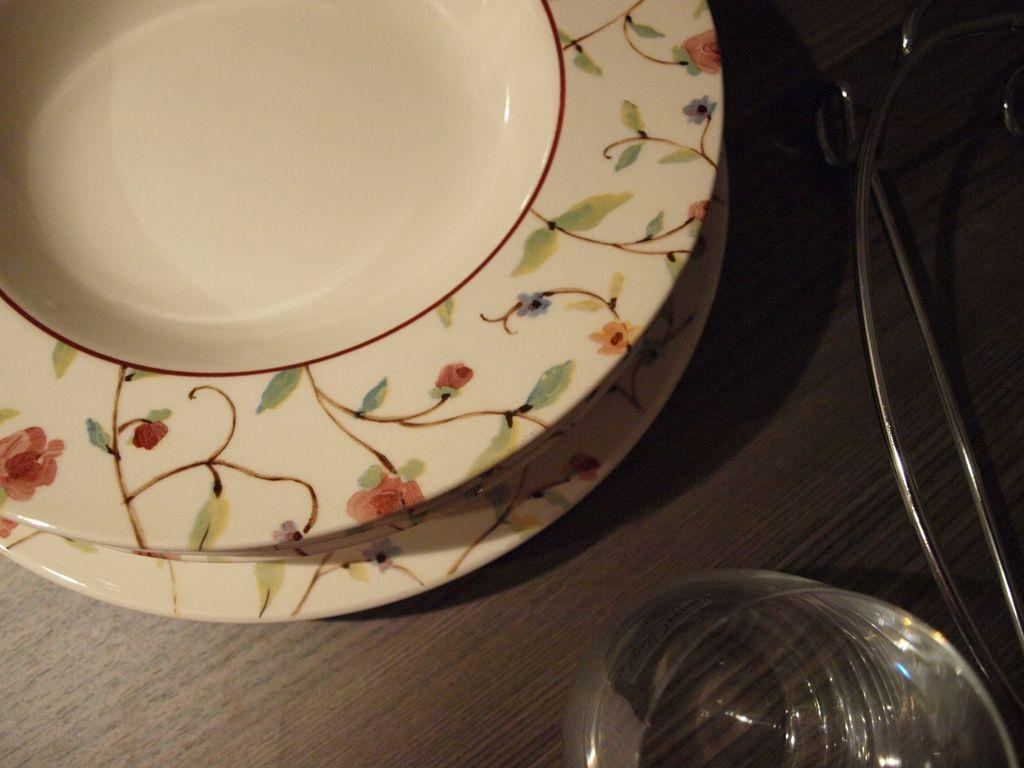What piece of furniture is present in the image? There is a table in the image. What objects are placed on the table? There are plates and a bowl on the table. Can you describe the arrangement of the objects on the table? The plates and bowl are placed on the table, but the specific arrangement cannot be determined from the provided facts. What type of milk is being served in the bowl on the table? There is no milk present in the image; it only shows plates and a bowl on the table. 